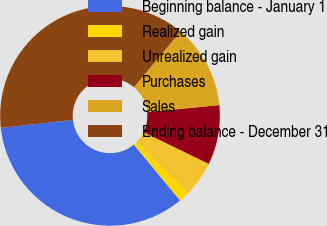Convert chart to OTSL. <chart><loc_0><loc_0><loc_500><loc_500><pie_chart><fcel>Beginning balance - January 1<fcel>Realized gain<fcel>Unrealized gain<fcel>Purchases<fcel>Sales<fcel>Ending balance - December 31<nl><fcel>34.26%<fcel>1.6%<fcel>5.18%<fcel>8.77%<fcel>12.35%<fcel>37.84%<nl></chart> 